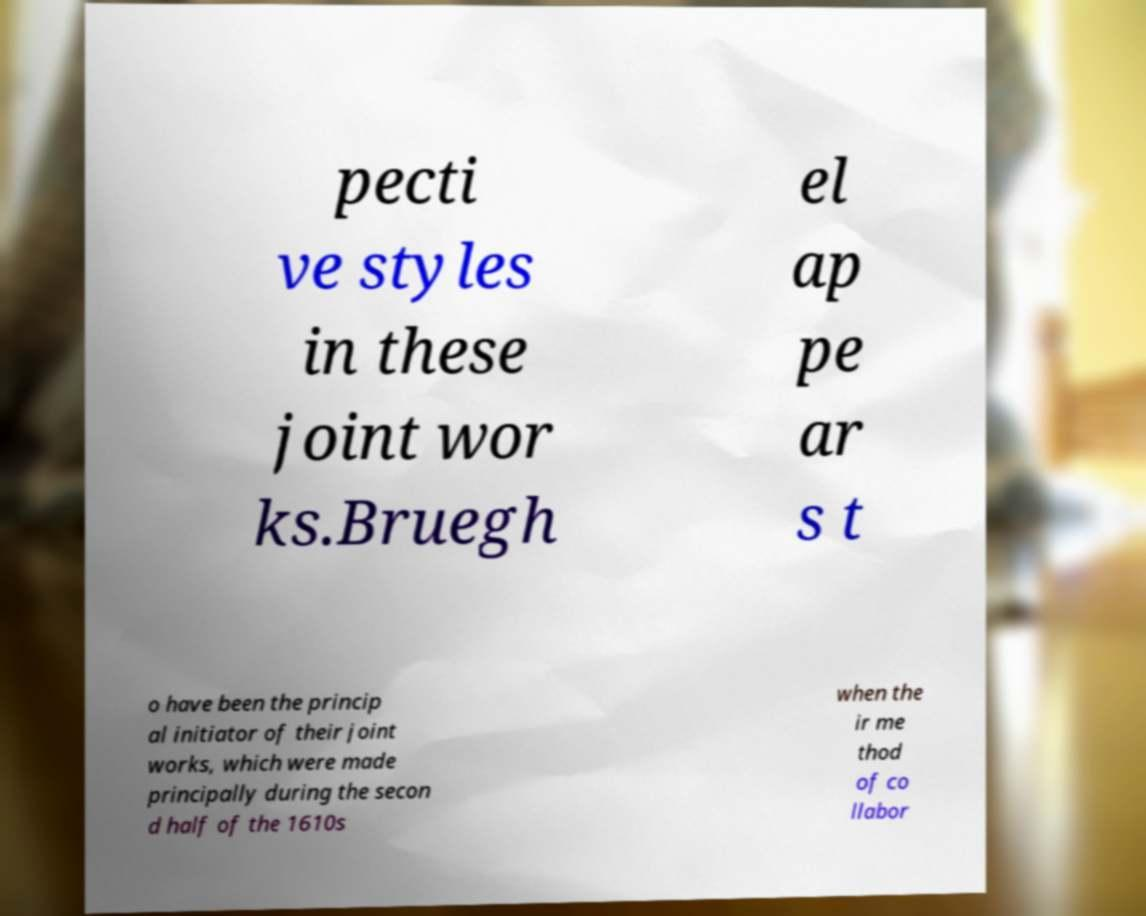I need the written content from this picture converted into text. Can you do that? pecti ve styles in these joint wor ks.Bruegh el ap pe ar s t o have been the princip al initiator of their joint works, which were made principally during the secon d half of the 1610s when the ir me thod of co llabor 